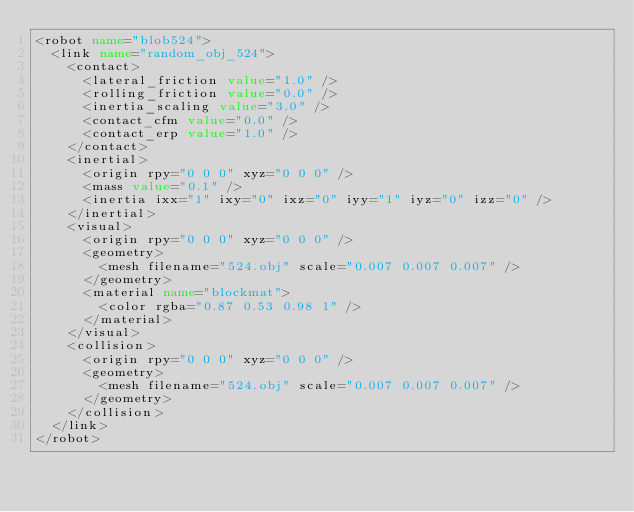<code> <loc_0><loc_0><loc_500><loc_500><_XML_><robot name="blob524">
  <link name="random_obj_524">
    <contact>
      <lateral_friction value="1.0" />
      <rolling_friction value="0.0" />
      <inertia_scaling value="3.0" />
      <contact_cfm value="0.0" />
      <contact_erp value="1.0" />
    </contact>
    <inertial>
      <origin rpy="0 0 0" xyz="0 0 0" />
      <mass value="0.1" />
      <inertia ixx="1" ixy="0" ixz="0" iyy="1" iyz="0" izz="0" />
    </inertial>
    <visual>
      <origin rpy="0 0 0" xyz="0 0 0" />
      <geometry>
        <mesh filename="524.obj" scale="0.007 0.007 0.007" />
      </geometry>
      <material name="blockmat">
        <color rgba="0.87 0.53 0.98 1" />
      </material>
    </visual>
    <collision>
      <origin rpy="0 0 0" xyz="0 0 0" />
      <geometry>
        <mesh filename="524.obj" scale="0.007 0.007 0.007" />
      </geometry>
    </collision>
  </link>
</robot></code> 